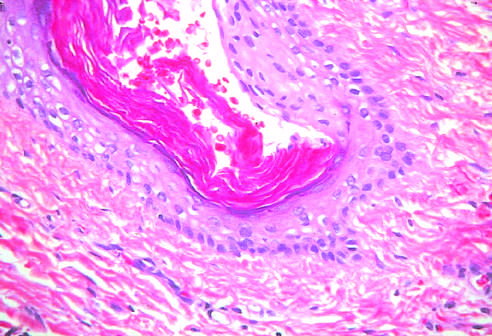what contain mature cells from endodermal, mesodermal, and ectodermal lines?
Answer the question using a single word or phrase. Testicular teratomas 